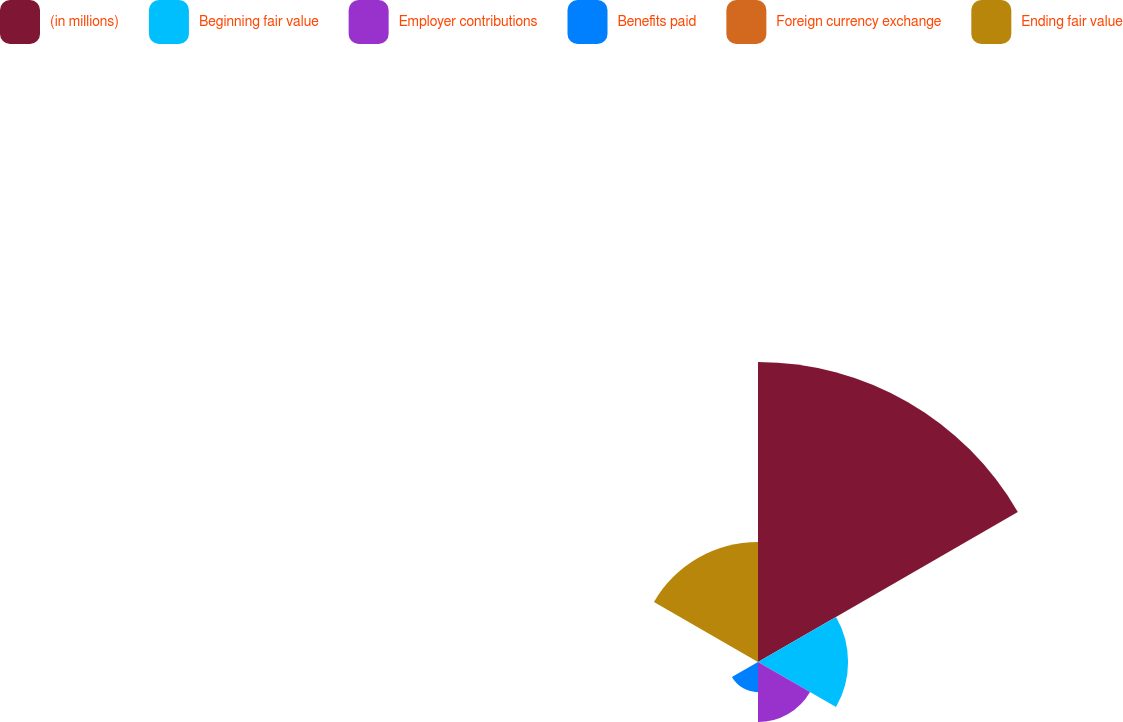Convert chart to OTSL. <chart><loc_0><loc_0><loc_500><loc_500><pie_chart><fcel>(in millions)<fcel>Beginning fair value<fcel>Employer contributions<fcel>Benefits paid<fcel>Foreign currency exchange<fcel>Ending fair value<nl><fcel>49.95%<fcel>15.0%<fcel>10.01%<fcel>5.02%<fcel>0.02%<fcel>20.0%<nl></chart> 